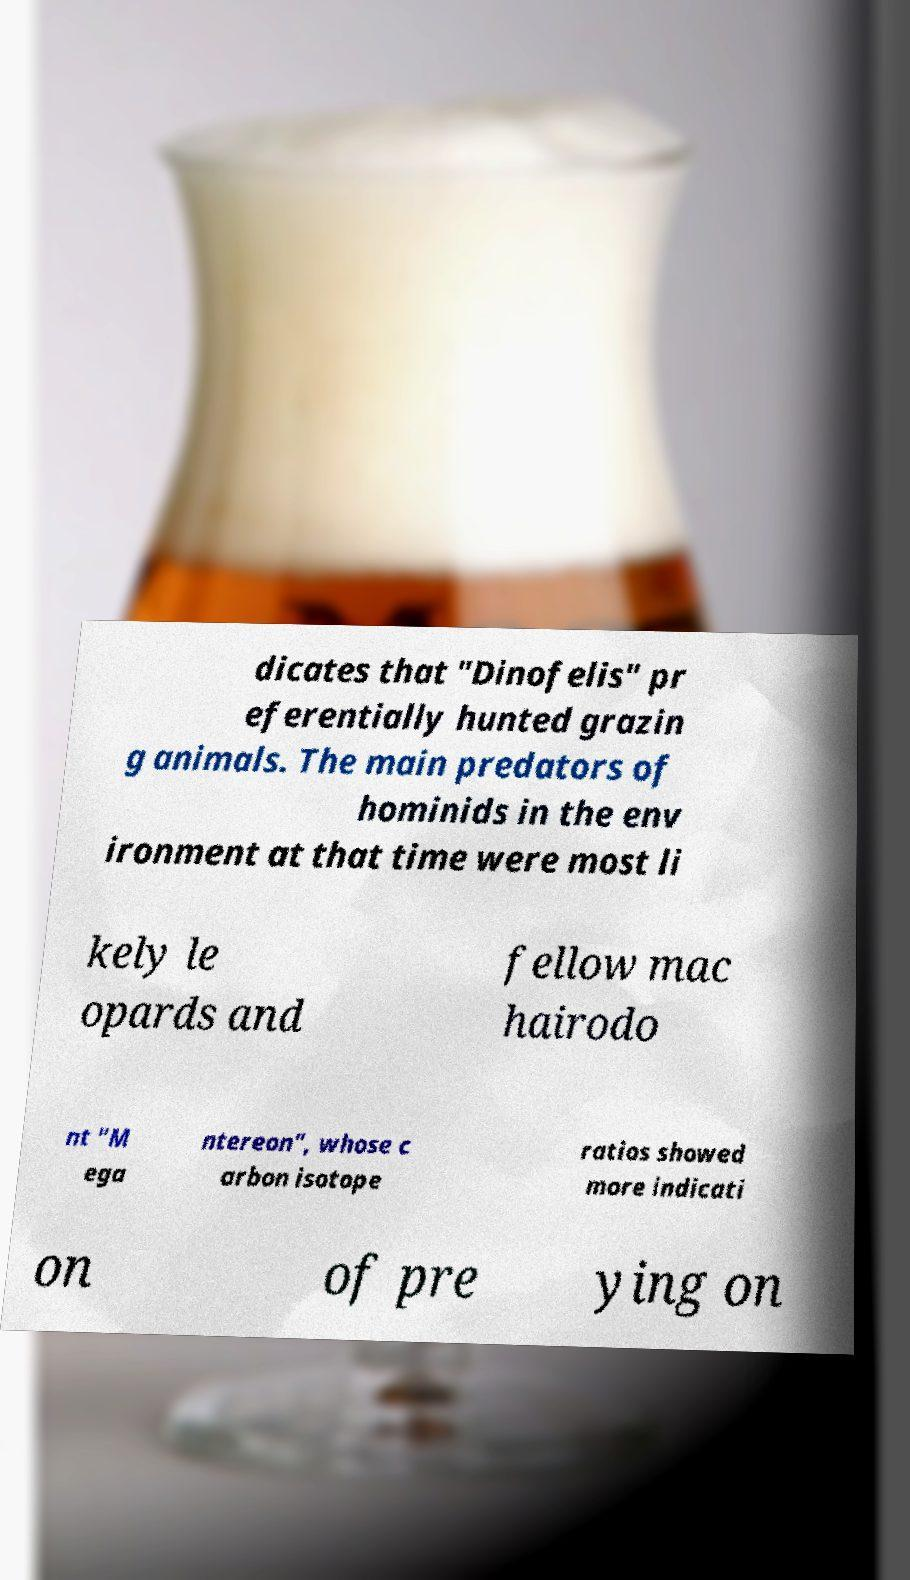I need the written content from this picture converted into text. Can you do that? dicates that "Dinofelis" pr eferentially hunted grazin g animals. The main predators of hominids in the env ironment at that time were most li kely le opards and fellow mac hairodo nt "M ega ntereon", whose c arbon isotope ratios showed more indicati on of pre ying on 